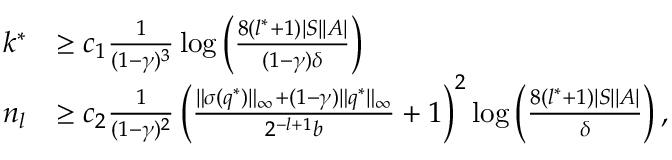<formula> <loc_0><loc_0><loc_500><loc_500>\begin{array} { r l } { k ^ { * } } & { \geq c _ { 1 } \frac { 1 } { ( 1 - \gamma ) ^ { 3 } } \log \left ( \frac { 8 ( l ^ { * } + 1 ) | S | | A | } { ( 1 - \gamma ) \delta } \right ) } \\ { n _ { l } } & { \geq c _ { 2 } \frac { 1 } { ( 1 - \gamma ) ^ { 2 } } \left ( \frac { \| \sigma ( q ^ { * } ) \| _ { \infty } + ( 1 - \gamma ) \| q ^ { * } \| _ { \infty } } { 2 ^ { - l + 1 } b } + 1 \right ) ^ { 2 } \log \left ( \frac { 8 ( l ^ { * } + 1 ) | S | | A | } { \delta } \right ) , } \end{array}</formula> 